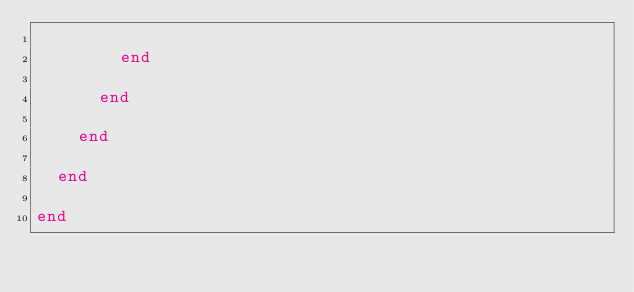Convert code to text. <code><loc_0><loc_0><loc_500><loc_500><_Ruby_>
        end

      end

    end

  end

end
</code> 